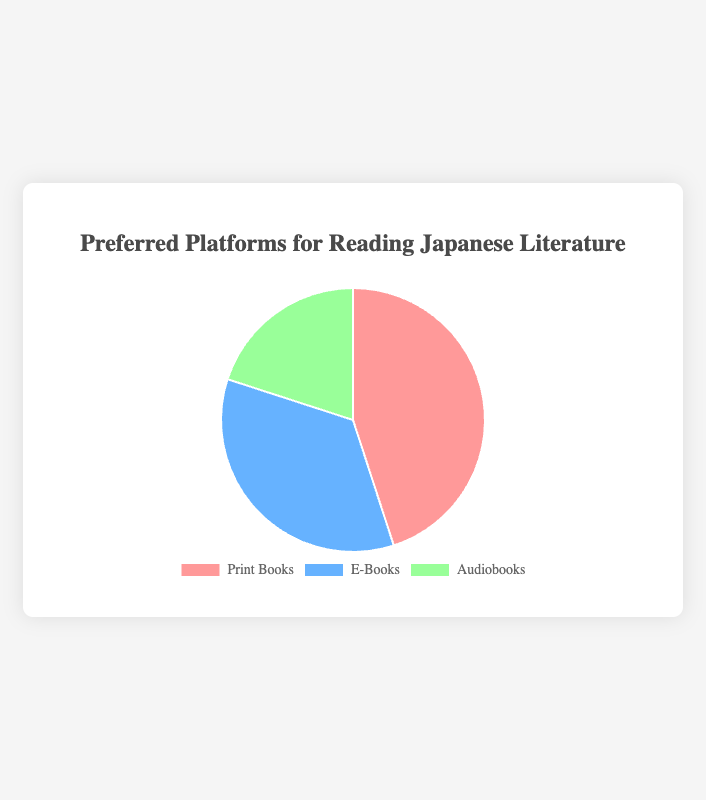Which platform has the highest percentage preference? The slice corresponding to Print Books has the largest percentage, indicated as 45%.
Answer: Print Books What's the sum of percentages for E-Books and Audiobooks? The percentage for E-Books is 35% and for Audiobooks is 20%. Adding these together: 35 + 20 = 55.
Answer: 55% How much more popular are Print Books compared to Audiobooks? Print Books have a preference of 45% and Audiobooks have 20%. The difference is calculated as 45 - 20 = 25.
Answer: 25% What is the least preferred platform for reading Japanese literature? The smallest slice of the pie chart corresponds to Audiobooks, which has a percentage of 20%.
Answer: Audiobooks Which two platforms, combined, have a preference that surpasses 50%? Both Print Books and E-Books together: 45% + 35% = 80%, and both E-Books and Audiobooks together: 35% + 20% = 55%. Either of these combinations surpasses 50%.
Answer: Print Books and E-Books or E-Books and Audiobooks What is the difference in preference between E-Books and Print Books? The percentage for Print Books is 45% and for E-Books is 35%. The difference is calculated as 45 - 35 = 10.
Answer: 10% If an additional platform was introduced with the same percentage as Audiobooks, what would be the total percentage excluding Print Books? With the current percentages, E-Books are 35%, Audiobooks are 20%, and the additional platform would also be 20%. Adding these: 35 + 20 + 20 = 75.
Answer: 75% How many times more popular are Print Books compared to Audiobooks? Print Books have a preference of 45% and Audiobooks have 20%. To find how many times more popular: 45 / 20 = 2.25.
Answer: 2.25 times Which platforms have a combined preference that equals or exceeds that of Print Books alone? Print Books have a preference of 45%. The combinations to check are: E-Books and Audiobooks (35 + 20 = 55). This combination exceeds 45%.
Answer: E-Books and Audiobooks 